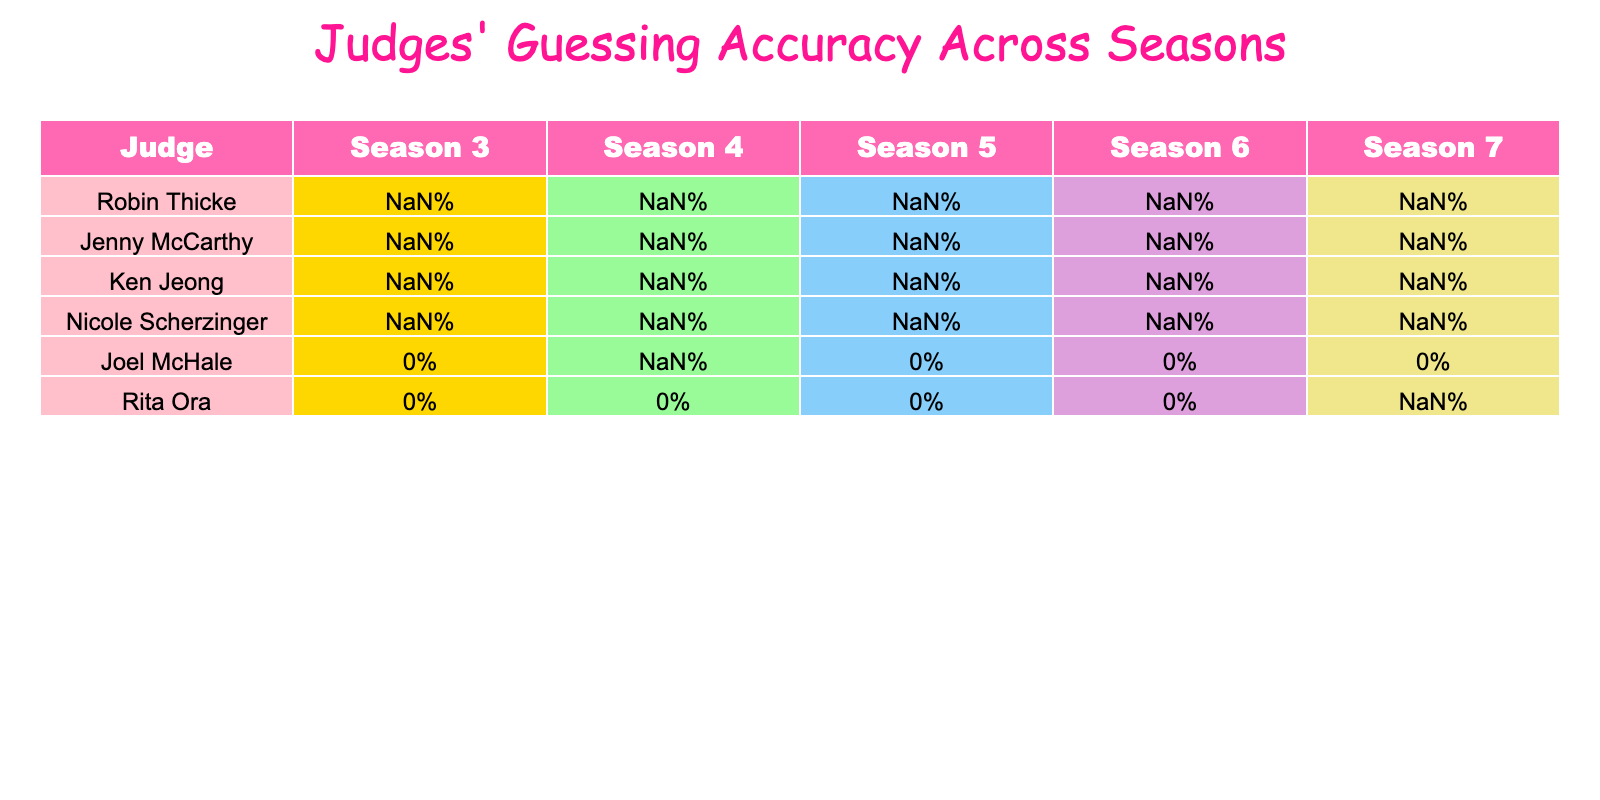What is Robin Thicke's guessing accuracy in Season 5? According to the table, Robin Thicke's guessing accuracy in Season 5 is listed as 65%.
Answer: 65% Which judge had the highest accuracy in Season 6? From the table, we can see that Nicole Scherzinger had the highest accuracy in Season 6, which is 64%.
Answer: Nicole Scherzinger What was the average accuracy of Ken Jeong across all seasons? By adding Ken Jeong's accuracy percentages: (32 + 29 + 35 + 31 + 33) = 160 and then dividing by the number of seasons (5), the average is 160/5 = 32%.
Answer: 32% Did Rita Ora participate in any seasons other than Season 7? The table shows that Rita Ora only has data for Season 7 with an accuracy of 54% and no data for the other seasons. Therefore, the answer is no.
Answer: No What is the difference in accuracy between Jenny McCarthy in Season 4 and Season 6? Jenny McCarthy's accuracy in Season 4 is 61% and in Season 6 it is 63%. The difference is calculated as 63% - 61% = 2%.
Answer: 2% Who had the lowest guessing accuracy in Season 3? Referring to the table, Ken Jeong had the lowest accuracy in Season 3 with 32%.
Answer: Ken Jeong What is the overall trend of Nicole Scherzinger's guessing accuracy from Season 3 to Season 7? Observing the table, Nicole's accuracy goes from 58% in Season 3 to 62% in Season 7. This indicates a slight upward trend over the seasons.
Answer: Upward trend Calculate the total accuracy of all judges in Season 4. We sum the accuracies of all judges in Season 4: (58 + 61 + 29 + 63 + 40) = 251%. However, we should only consider those with available data, which gives us 58 + 61 + 29 + 63 + 40 = 251. Since there are 5 judges, the total accuracy is 251%.
Answer: 251% 